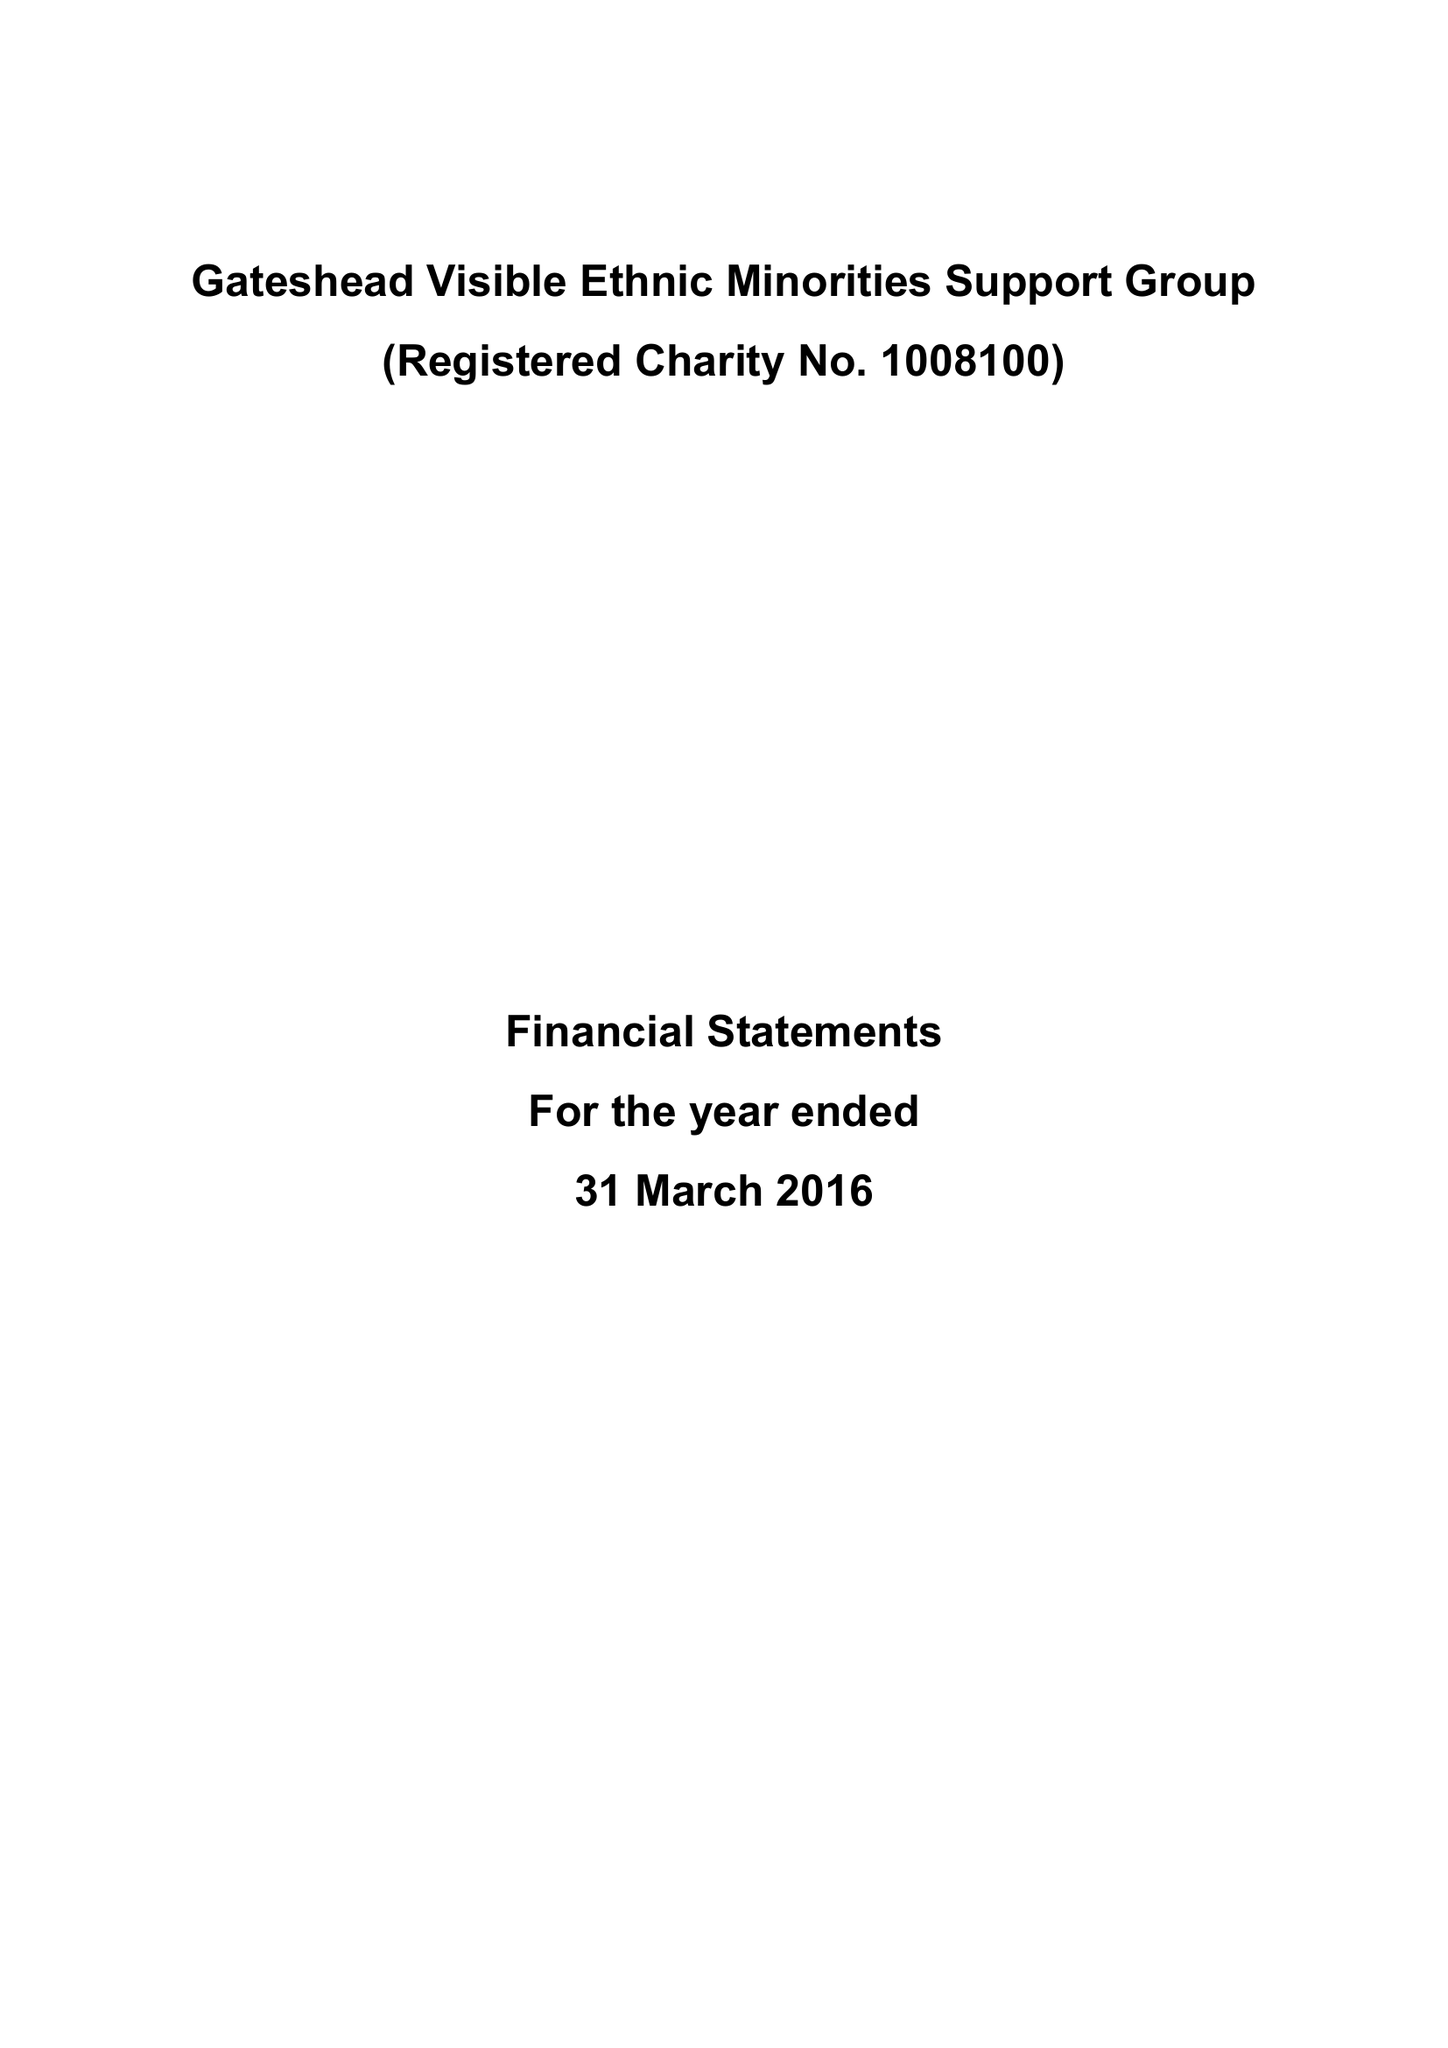What is the value for the charity_name?
Answer the question using a single word or phrase. Gateshead Visible Ethnic Minorities Support Group 